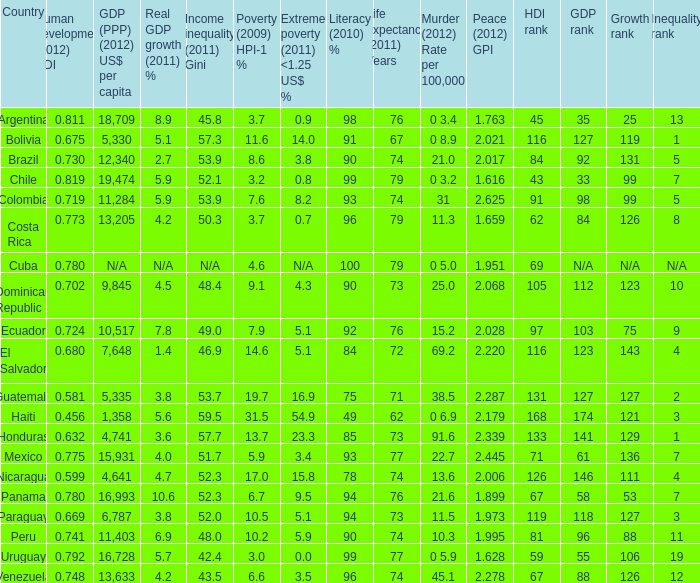What murder (2012) rate per 100,00 also has a 1.616 as the peace (2012) GPI? 0 3.2. 